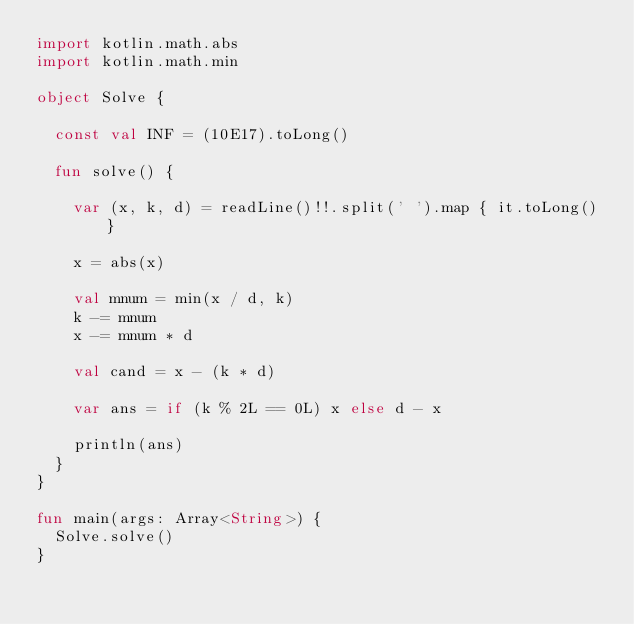Convert code to text. <code><loc_0><loc_0><loc_500><loc_500><_Kotlin_>import kotlin.math.abs
import kotlin.math.min

object Solve {

  const val INF = (10E17).toLong()

  fun solve() {

    var (x, k, d) = readLine()!!.split(' ').map { it.toLong() }

    x = abs(x)

    val mnum = min(x / d, k)
    k -= mnum
    x -= mnum * d

    val cand = x - (k * d)

    var ans = if (k % 2L == 0L) x else d - x

    println(ans)
  }
}

fun main(args: Array<String>) {
  Solve.solve()
}</code> 